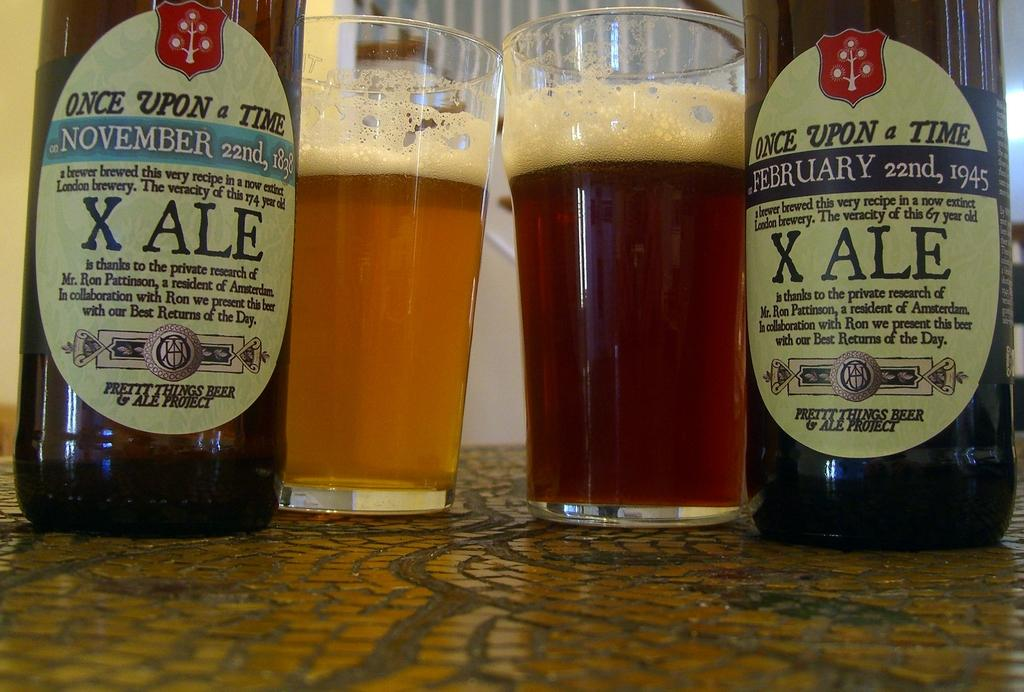<image>
Summarize the visual content of the image. Two bottles of X Ale Once upon of time drinks. 